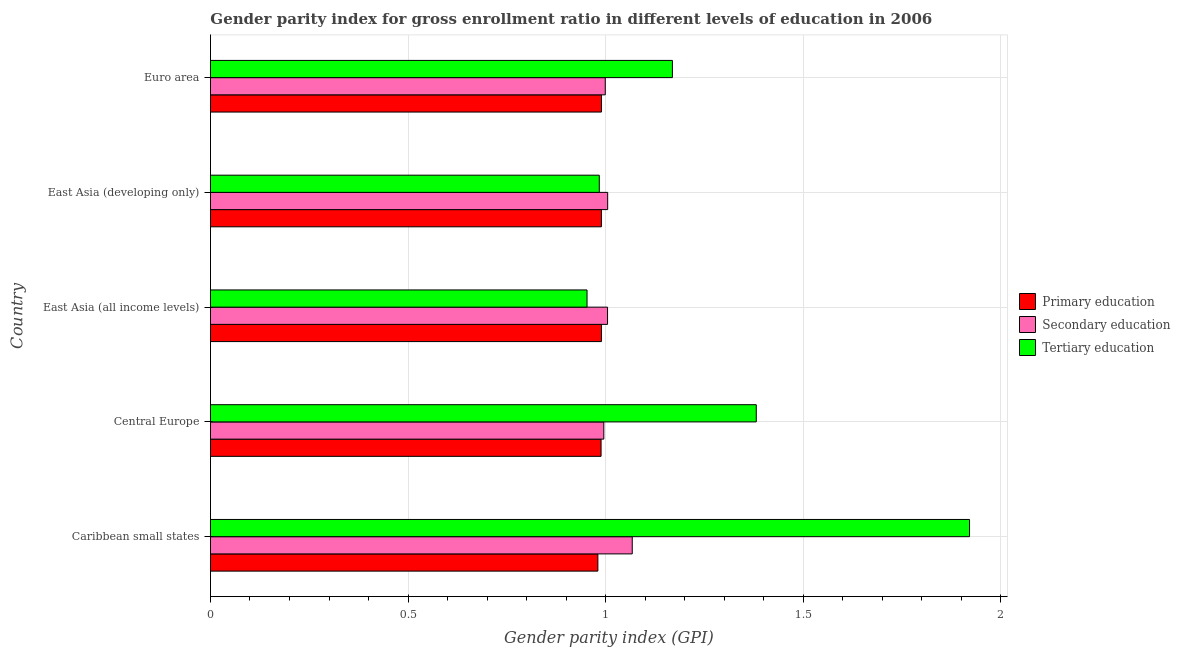How many different coloured bars are there?
Offer a very short reply. 3. How many groups of bars are there?
Make the answer very short. 5. Are the number of bars on each tick of the Y-axis equal?
Provide a short and direct response. Yes. What is the label of the 4th group of bars from the top?
Offer a very short reply. Central Europe. What is the gender parity index in tertiary education in Central Europe?
Your answer should be very brief. 1.38. Across all countries, what is the maximum gender parity index in primary education?
Provide a short and direct response. 0.99. Across all countries, what is the minimum gender parity index in primary education?
Offer a terse response. 0.98. In which country was the gender parity index in tertiary education maximum?
Make the answer very short. Caribbean small states. In which country was the gender parity index in primary education minimum?
Offer a terse response. Caribbean small states. What is the total gender parity index in tertiary education in the graph?
Give a very brief answer. 6.41. What is the difference between the gender parity index in tertiary education in East Asia (developing only) and that in Euro area?
Give a very brief answer. -0.18. What is the difference between the gender parity index in secondary education in Central Europe and the gender parity index in tertiary education in Euro area?
Ensure brevity in your answer.  -0.17. What is the difference between the gender parity index in primary education and gender parity index in secondary education in East Asia (developing only)?
Provide a succinct answer. -0.02. What is the ratio of the gender parity index in tertiary education in East Asia (all income levels) to that in Euro area?
Keep it short and to the point. 0.81. What is the difference between the highest and the second highest gender parity index in primary education?
Your answer should be compact. 0. What is the difference between the highest and the lowest gender parity index in secondary education?
Your answer should be very brief. 0.07. In how many countries, is the gender parity index in secondary education greater than the average gender parity index in secondary education taken over all countries?
Make the answer very short. 1. Is the sum of the gender parity index in primary education in Caribbean small states and East Asia (all income levels) greater than the maximum gender parity index in secondary education across all countries?
Keep it short and to the point. Yes. What does the 2nd bar from the top in Euro area represents?
Ensure brevity in your answer.  Secondary education. Is it the case that in every country, the sum of the gender parity index in primary education and gender parity index in secondary education is greater than the gender parity index in tertiary education?
Offer a terse response. Yes. Are all the bars in the graph horizontal?
Offer a terse response. Yes. Are the values on the major ticks of X-axis written in scientific E-notation?
Give a very brief answer. No. Does the graph contain any zero values?
Keep it short and to the point. No. How many legend labels are there?
Offer a terse response. 3. How are the legend labels stacked?
Make the answer very short. Vertical. What is the title of the graph?
Provide a short and direct response. Gender parity index for gross enrollment ratio in different levels of education in 2006. What is the label or title of the X-axis?
Offer a very short reply. Gender parity index (GPI). What is the label or title of the Y-axis?
Make the answer very short. Country. What is the Gender parity index (GPI) of Primary education in Caribbean small states?
Make the answer very short. 0.98. What is the Gender parity index (GPI) of Secondary education in Caribbean small states?
Give a very brief answer. 1.07. What is the Gender parity index (GPI) in Tertiary education in Caribbean small states?
Provide a succinct answer. 1.92. What is the Gender parity index (GPI) in Primary education in Central Europe?
Give a very brief answer. 0.99. What is the Gender parity index (GPI) of Secondary education in Central Europe?
Ensure brevity in your answer.  1. What is the Gender parity index (GPI) of Tertiary education in Central Europe?
Ensure brevity in your answer.  1.38. What is the Gender parity index (GPI) in Primary education in East Asia (all income levels)?
Provide a short and direct response. 0.99. What is the Gender parity index (GPI) of Secondary education in East Asia (all income levels)?
Offer a terse response. 1. What is the Gender parity index (GPI) in Tertiary education in East Asia (all income levels)?
Provide a succinct answer. 0.95. What is the Gender parity index (GPI) in Primary education in East Asia (developing only)?
Make the answer very short. 0.99. What is the Gender parity index (GPI) of Secondary education in East Asia (developing only)?
Your answer should be compact. 1.01. What is the Gender parity index (GPI) of Tertiary education in East Asia (developing only)?
Offer a very short reply. 0.98. What is the Gender parity index (GPI) of Primary education in Euro area?
Keep it short and to the point. 0.99. What is the Gender parity index (GPI) in Secondary education in Euro area?
Provide a succinct answer. 1. What is the Gender parity index (GPI) in Tertiary education in Euro area?
Provide a short and direct response. 1.17. Across all countries, what is the maximum Gender parity index (GPI) of Primary education?
Your answer should be compact. 0.99. Across all countries, what is the maximum Gender parity index (GPI) in Secondary education?
Provide a short and direct response. 1.07. Across all countries, what is the maximum Gender parity index (GPI) of Tertiary education?
Offer a terse response. 1.92. Across all countries, what is the minimum Gender parity index (GPI) of Primary education?
Your answer should be compact. 0.98. Across all countries, what is the minimum Gender parity index (GPI) in Secondary education?
Your response must be concise. 1. Across all countries, what is the minimum Gender parity index (GPI) of Tertiary education?
Make the answer very short. 0.95. What is the total Gender parity index (GPI) in Primary education in the graph?
Ensure brevity in your answer.  4.94. What is the total Gender parity index (GPI) in Secondary education in the graph?
Offer a terse response. 5.07. What is the total Gender parity index (GPI) of Tertiary education in the graph?
Make the answer very short. 6.41. What is the difference between the Gender parity index (GPI) of Primary education in Caribbean small states and that in Central Europe?
Your answer should be compact. -0.01. What is the difference between the Gender parity index (GPI) in Secondary education in Caribbean small states and that in Central Europe?
Your answer should be very brief. 0.07. What is the difference between the Gender parity index (GPI) in Tertiary education in Caribbean small states and that in Central Europe?
Offer a very short reply. 0.54. What is the difference between the Gender parity index (GPI) of Primary education in Caribbean small states and that in East Asia (all income levels)?
Keep it short and to the point. -0.01. What is the difference between the Gender parity index (GPI) in Secondary education in Caribbean small states and that in East Asia (all income levels)?
Provide a short and direct response. 0.06. What is the difference between the Gender parity index (GPI) in Tertiary education in Caribbean small states and that in East Asia (all income levels)?
Your answer should be very brief. 0.97. What is the difference between the Gender parity index (GPI) in Primary education in Caribbean small states and that in East Asia (developing only)?
Ensure brevity in your answer.  -0.01. What is the difference between the Gender parity index (GPI) of Secondary education in Caribbean small states and that in East Asia (developing only)?
Give a very brief answer. 0.06. What is the difference between the Gender parity index (GPI) of Tertiary education in Caribbean small states and that in East Asia (developing only)?
Give a very brief answer. 0.94. What is the difference between the Gender parity index (GPI) in Primary education in Caribbean small states and that in Euro area?
Offer a terse response. -0.01. What is the difference between the Gender parity index (GPI) of Secondary education in Caribbean small states and that in Euro area?
Offer a terse response. 0.07. What is the difference between the Gender parity index (GPI) of Tertiary education in Caribbean small states and that in Euro area?
Keep it short and to the point. 0.75. What is the difference between the Gender parity index (GPI) of Primary education in Central Europe and that in East Asia (all income levels)?
Your answer should be very brief. -0. What is the difference between the Gender parity index (GPI) of Secondary education in Central Europe and that in East Asia (all income levels)?
Your answer should be very brief. -0.01. What is the difference between the Gender parity index (GPI) in Tertiary education in Central Europe and that in East Asia (all income levels)?
Provide a short and direct response. 0.43. What is the difference between the Gender parity index (GPI) of Primary education in Central Europe and that in East Asia (developing only)?
Offer a terse response. -0. What is the difference between the Gender parity index (GPI) of Secondary education in Central Europe and that in East Asia (developing only)?
Your answer should be very brief. -0.01. What is the difference between the Gender parity index (GPI) in Tertiary education in Central Europe and that in East Asia (developing only)?
Offer a very short reply. 0.4. What is the difference between the Gender parity index (GPI) of Primary education in Central Europe and that in Euro area?
Ensure brevity in your answer.  -0. What is the difference between the Gender parity index (GPI) in Secondary education in Central Europe and that in Euro area?
Give a very brief answer. -0. What is the difference between the Gender parity index (GPI) in Tertiary education in Central Europe and that in Euro area?
Offer a terse response. 0.21. What is the difference between the Gender parity index (GPI) in Primary education in East Asia (all income levels) and that in East Asia (developing only)?
Your answer should be very brief. 0. What is the difference between the Gender parity index (GPI) of Secondary education in East Asia (all income levels) and that in East Asia (developing only)?
Offer a terse response. -0. What is the difference between the Gender parity index (GPI) in Tertiary education in East Asia (all income levels) and that in East Asia (developing only)?
Provide a succinct answer. -0.03. What is the difference between the Gender parity index (GPI) of Primary education in East Asia (all income levels) and that in Euro area?
Offer a terse response. 0. What is the difference between the Gender parity index (GPI) in Secondary education in East Asia (all income levels) and that in Euro area?
Provide a succinct answer. 0.01. What is the difference between the Gender parity index (GPI) of Tertiary education in East Asia (all income levels) and that in Euro area?
Offer a terse response. -0.22. What is the difference between the Gender parity index (GPI) of Primary education in East Asia (developing only) and that in Euro area?
Offer a terse response. -0. What is the difference between the Gender parity index (GPI) in Secondary education in East Asia (developing only) and that in Euro area?
Offer a very short reply. 0.01. What is the difference between the Gender parity index (GPI) in Tertiary education in East Asia (developing only) and that in Euro area?
Provide a short and direct response. -0.19. What is the difference between the Gender parity index (GPI) of Primary education in Caribbean small states and the Gender parity index (GPI) of Secondary education in Central Europe?
Provide a short and direct response. -0.01. What is the difference between the Gender parity index (GPI) of Primary education in Caribbean small states and the Gender parity index (GPI) of Tertiary education in Central Europe?
Keep it short and to the point. -0.4. What is the difference between the Gender parity index (GPI) in Secondary education in Caribbean small states and the Gender parity index (GPI) in Tertiary education in Central Europe?
Offer a very short reply. -0.31. What is the difference between the Gender parity index (GPI) of Primary education in Caribbean small states and the Gender parity index (GPI) of Secondary education in East Asia (all income levels)?
Provide a short and direct response. -0.02. What is the difference between the Gender parity index (GPI) in Primary education in Caribbean small states and the Gender parity index (GPI) in Tertiary education in East Asia (all income levels)?
Offer a terse response. 0.03. What is the difference between the Gender parity index (GPI) in Secondary education in Caribbean small states and the Gender parity index (GPI) in Tertiary education in East Asia (all income levels)?
Offer a terse response. 0.11. What is the difference between the Gender parity index (GPI) in Primary education in Caribbean small states and the Gender parity index (GPI) in Secondary education in East Asia (developing only)?
Provide a short and direct response. -0.02. What is the difference between the Gender parity index (GPI) of Primary education in Caribbean small states and the Gender parity index (GPI) of Tertiary education in East Asia (developing only)?
Provide a succinct answer. -0. What is the difference between the Gender parity index (GPI) in Secondary education in Caribbean small states and the Gender parity index (GPI) in Tertiary education in East Asia (developing only)?
Ensure brevity in your answer.  0.08. What is the difference between the Gender parity index (GPI) of Primary education in Caribbean small states and the Gender parity index (GPI) of Secondary education in Euro area?
Your response must be concise. -0.02. What is the difference between the Gender parity index (GPI) in Primary education in Caribbean small states and the Gender parity index (GPI) in Tertiary education in Euro area?
Provide a succinct answer. -0.19. What is the difference between the Gender parity index (GPI) in Secondary education in Caribbean small states and the Gender parity index (GPI) in Tertiary education in Euro area?
Offer a terse response. -0.1. What is the difference between the Gender parity index (GPI) of Primary education in Central Europe and the Gender parity index (GPI) of Secondary education in East Asia (all income levels)?
Offer a terse response. -0.02. What is the difference between the Gender parity index (GPI) in Primary education in Central Europe and the Gender parity index (GPI) in Tertiary education in East Asia (all income levels)?
Provide a short and direct response. 0.04. What is the difference between the Gender parity index (GPI) of Secondary education in Central Europe and the Gender parity index (GPI) of Tertiary education in East Asia (all income levels)?
Keep it short and to the point. 0.04. What is the difference between the Gender parity index (GPI) in Primary education in Central Europe and the Gender parity index (GPI) in Secondary education in East Asia (developing only)?
Provide a succinct answer. -0.02. What is the difference between the Gender parity index (GPI) of Primary education in Central Europe and the Gender parity index (GPI) of Tertiary education in East Asia (developing only)?
Offer a very short reply. 0. What is the difference between the Gender parity index (GPI) of Secondary education in Central Europe and the Gender parity index (GPI) of Tertiary education in East Asia (developing only)?
Give a very brief answer. 0.01. What is the difference between the Gender parity index (GPI) of Primary education in Central Europe and the Gender parity index (GPI) of Secondary education in Euro area?
Your answer should be compact. -0.01. What is the difference between the Gender parity index (GPI) in Primary education in Central Europe and the Gender parity index (GPI) in Tertiary education in Euro area?
Give a very brief answer. -0.18. What is the difference between the Gender parity index (GPI) of Secondary education in Central Europe and the Gender parity index (GPI) of Tertiary education in Euro area?
Your answer should be very brief. -0.17. What is the difference between the Gender parity index (GPI) in Primary education in East Asia (all income levels) and the Gender parity index (GPI) in Secondary education in East Asia (developing only)?
Your answer should be very brief. -0.02. What is the difference between the Gender parity index (GPI) in Primary education in East Asia (all income levels) and the Gender parity index (GPI) in Tertiary education in East Asia (developing only)?
Offer a terse response. 0.01. What is the difference between the Gender parity index (GPI) of Secondary education in East Asia (all income levels) and the Gender parity index (GPI) of Tertiary education in East Asia (developing only)?
Your answer should be compact. 0.02. What is the difference between the Gender parity index (GPI) of Primary education in East Asia (all income levels) and the Gender parity index (GPI) of Secondary education in Euro area?
Give a very brief answer. -0.01. What is the difference between the Gender parity index (GPI) of Primary education in East Asia (all income levels) and the Gender parity index (GPI) of Tertiary education in Euro area?
Give a very brief answer. -0.18. What is the difference between the Gender parity index (GPI) in Secondary education in East Asia (all income levels) and the Gender parity index (GPI) in Tertiary education in Euro area?
Ensure brevity in your answer.  -0.16. What is the difference between the Gender parity index (GPI) of Primary education in East Asia (developing only) and the Gender parity index (GPI) of Secondary education in Euro area?
Your answer should be compact. -0.01. What is the difference between the Gender parity index (GPI) of Primary education in East Asia (developing only) and the Gender parity index (GPI) of Tertiary education in Euro area?
Offer a terse response. -0.18. What is the difference between the Gender parity index (GPI) of Secondary education in East Asia (developing only) and the Gender parity index (GPI) of Tertiary education in Euro area?
Offer a terse response. -0.16. What is the average Gender parity index (GPI) of Primary education per country?
Make the answer very short. 0.99. What is the average Gender parity index (GPI) of Secondary education per country?
Offer a terse response. 1.01. What is the average Gender parity index (GPI) in Tertiary education per country?
Give a very brief answer. 1.28. What is the difference between the Gender parity index (GPI) in Primary education and Gender parity index (GPI) in Secondary education in Caribbean small states?
Keep it short and to the point. -0.09. What is the difference between the Gender parity index (GPI) of Primary education and Gender parity index (GPI) of Tertiary education in Caribbean small states?
Make the answer very short. -0.94. What is the difference between the Gender parity index (GPI) in Secondary education and Gender parity index (GPI) in Tertiary education in Caribbean small states?
Ensure brevity in your answer.  -0.85. What is the difference between the Gender parity index (GPI) in Primary education and Gender parity index (GPI) in Secondary education in Central Europe?
Make the answer very short. -0.01. What is the difference between the Gender parity index (GPI) of Primary education and Gender parity index (GPI) of Tertiary education in Central Europe?
Offer a very short reply. -0.39. What is the difference between the Gender parity index (GPI) of Secondary education and Gender parity index (GPI) of Tertiary education in Central Europe?
Provide a succinct answer. -0.39. What is the difference between the Gender parity index (GPI) in Primary education and Gender parity index (GPI) in Secondary education in East Asia (all income levels)?
Offer a terse response. -0.02. What is the difference between the Gender parity index (GPI) of Primary education and Gender parity index (GPI) of Tertiary education in East Asia (all income levels)?
Keep it short and to the point. 0.04. What is the difference between the Gender parity index (GPI) of Secondary education and Gender parity index (GPI) of Tertiary education in East Asia (all income levels)?
Give a very brief answer. 0.05. What is the difference between the Gender parity index (GPI) of Primary education and Gender parity index (GPI) of Secondary education in East Asia (developing only)?
Give a very brief answer. -0.02. What is the difference between the Gender parity index (GPI) of Primary education and Gender parity index (GPI) of Tertiary education in East Asia (developing only)?
Make the answer very short. 0.01. What is the difference between the Gender parity index (GPI) of Secondary education and Gender parity index (GPI) of Tertiary education in East Asia (developing only)?
Offer a terse response. 0.02. What is the difference between the Gender parity index (GPI) in Primary education and Gender parity index (GPI) in Secondary education in Euro area?
Keep it short and to the point. -0.01. What is the difference between the Gender parity index (GPI) of Primary education and Gender parity index (GPI) of Tertiary education in Euro area?
Keep it short and to the point. -0.18. What is the difference between the Gender parity index (GPI) of Secondary education and Gender parity index (GPI) of Tertiary education in Euro area?
Provide a succinct answer. -0.17. What is the ratio of the Gender parity index (GPI) of Primary education in Caribbean small states to that in Central Europe?
Make the answer very short. 0.99. What is the ratio of the Gender parity index (GPI) of Secondary education in Caribbean small states to that in Central Europe?
Give a very brief answer. 1.07. What is the ratio of the Gender parity index (GPI) in Tertiary education in Caribbean small states to that in Central Europe?
Keep it short and to the point. 1.39. What is the ratio of the Gender parity index (GPI) of Primary education in Caribbean small states to that in East Asia (all income levels)?
Your answer should be compact. 0.99. What is the ratio of the Gender parity index (GPI) in Secondary education in Caribbean small states to that in East Asia (all income levels)?
Provide a succinct answer. 1.06. What is the ratio of the Gender parity index (GPI) in Tertiary education in Caribbean small states to that in East Asia (all income levels)?
Provide a short and direct response. 2.02. What is the ratio of the Gender parity index (GPI) of Primary education in Caribbean small states to that in East Asia (developing only)?
Your answer should be compact. 0.99. What is the ratio of the Gender parity index (GPI) in Secondary education in Caribbean small states to that in East Asia (developing only)?
Offer a terse response. 1.06. What is the ratio of the Gender parity index (GPI) of Tertiary education in Caribbean small states to that in East Asia (developing only)?
Your response must be concise. 1.95. What is the ratio of the Gender parity index (GPI) in Primary education in Caribbean small states to that in Euro area?
Offer a terse response. 0.99. What is the ratio of the Gender parity index (GPI) of Secondary education in Caribbean small states to that in Euro area?
Offer a very short reply. 1.07. What is the ratio of the Gender parity index (GPI) in Tertiary education in Caribbean small states to that in Euro area?
Ensure brevity in your answer.  1.64. What is the ratio of the Gender parity index (GPI) of Primary education in Central Europe to that in East Asia (all income levels)?
Your answer should be very brief. 1. What is the ratio of the Gender parity index (GPI) of Secondary education in Central Europe to that in East Asia (all income levels)?
Offer a very short reply. 0.99. What is the ratio of the Gender parity index (GPI) of Tertiary education in Central Europe to that in East Asia (all income levels)?
Make the answer very short. 1.45. What is the ratio of the Gender parity index (GPI) in Primary education in Central Europe to that in East Asia (developing only)?
Offer a very short reply. 1. What is the ratio of the Gender parity index (GPI) in Secondary education in Central Europe to that in East Asia (developing only)?
Make the answer very short. 0.99. What is the ratio of the Gender parity index (GPI) of Tertiary education in Central Europe to that in East Asia (developing only)?
Keep it short and to the point. 1.4. What is the ratio of the Gender parity index (GPI) in Secondary education in Central Europe to that in Euro area?
Your answer should be compact. 1. What is the ratio of the Gender parity index (GPI) of Tertiary education in Central Europe to that in Euro area?
Your answer should be very brief. 1.18. What is the ratio of the Gender parity index (GPI) of Secondary education in East Asia (all income levels) to that in East Asia (developing only)?
Make the answer very short. 1. What is the ratio of the Gender parity index (GPI) of Tertiary education in East Asia (all income levels) to that in East Asia (developing only)?
Your response must be concise. 0.97. What is the ratio of the Gender parity index (GPI) in Secondary education in East Asia (all income levels) to that in Euro area?
Keep it short and to the point. 1.01. What is the ratio of the Gender parity index (GPI) in Tertiary education in East Asia (all income levels) to that in Euro area?
Offer a terse response. 0.82. What is the ratio of the Gender parity index (GPI) in Primary education in East Asia (developing only) to that in Euro area?
Your answer should be compact. 1. What is the ratio of the Gender parity index (GPI) of Secondary education in East Asia (developing only) to that in Euro area?
Give a very brief answer. 1.01. What is the ratio of the Gender parity index (GPI) in Tertiary education in East Asia (developing only) to that in Euro area?
Your answer should be very brief. 0.84. What is the difference between the highest and the second highest Gender parity index (GPI) of Primary education?
Your answer should be very brief. 0. What is the difference between the highest and the second highest Gender parity index (GPI) in Secondary education?
Your answer should be very brief. 0.06. What is the difference between the highest and the second highest Gender parity index (GPI) of Tertiary education?
Ensure brevity in your answer.  0.54. What is the difference between the highest and the lowest Gender parity index (GPI) in Primary education?
Offer a very short reply. 0.01. What is the difference between the highest and the lowest Gender parity index (GPI) in Secondary education?
Your answer should be very brief. 0.07. What is the difference between the highest and the lowest Gender parity index (GPI) in Tertiary education?
Provide a short and direct response. 0.97. 